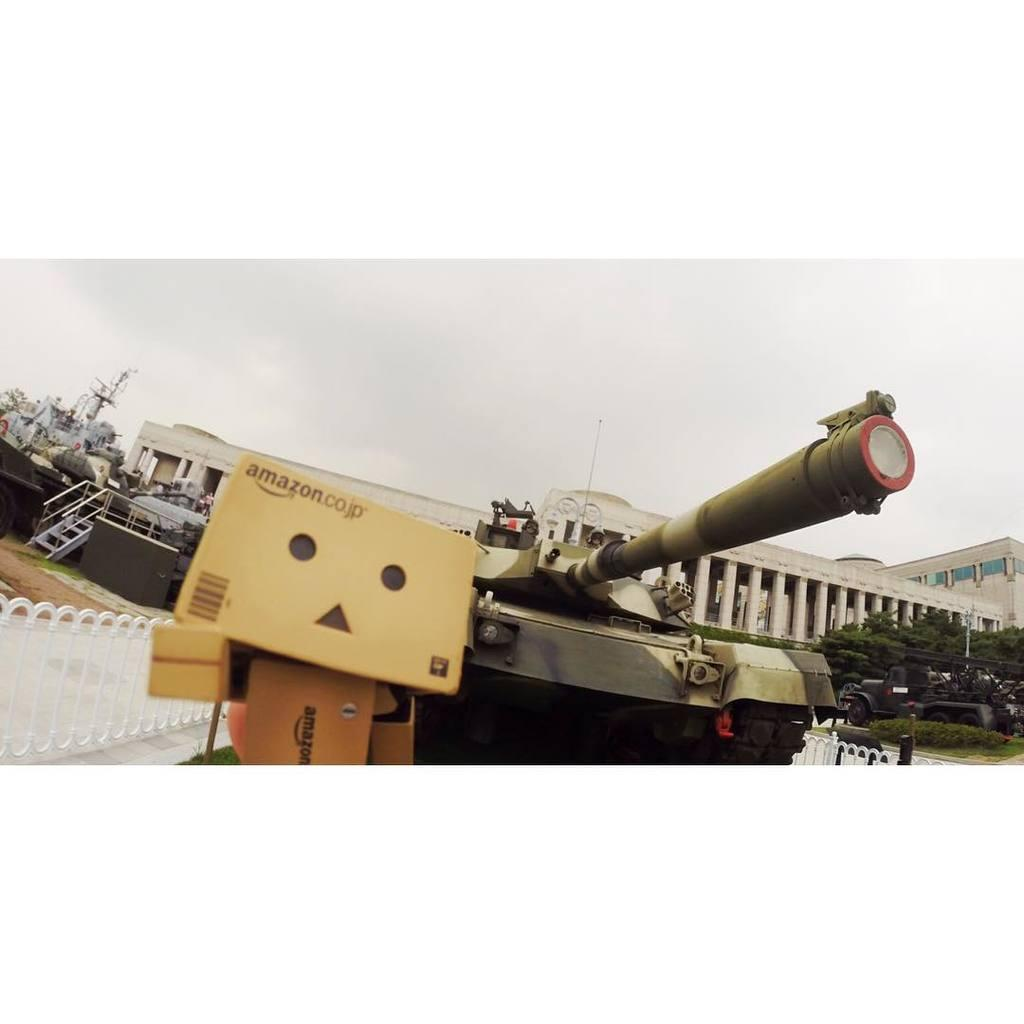What is the main subject of the picture? The main subject of the picture is a tanker. What other objects can be seen in the picture? There are cardboard boxes, a fence, shrubs, trees, and a building visible in the picture. Can you describe the background of the picture? The sky in the background is cloudy. What type of finger can be seen operating the engine in the picture? There is no finger or engine present in the picture; it features a tanker, cardboard boxes, a fence, shrubs, trees, and a building. 